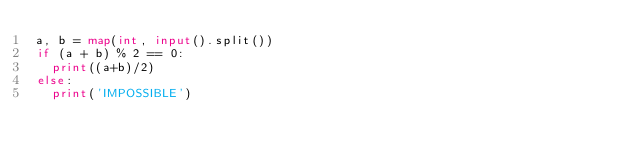<code> <loc_0><loc_0><loc_500><loc_500><_Python_>a, b = map(int, input().split())
if (a + b) % 2 == 0:
  print((a+b)/2)
else:
  print('IMPOSSIBLE')</code> 